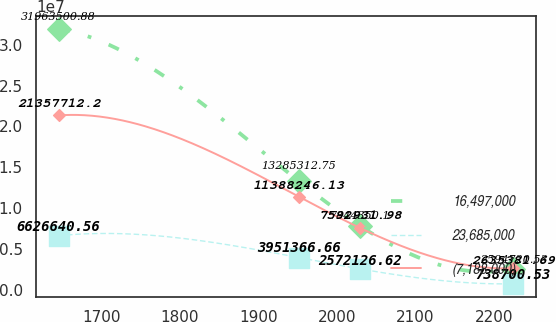Convert chart to OTSL. <chart><loc_0><loc_0><loc_500><loc_500><line_chart><ecel><fcel>16,497,000<fcel>23,685,000<fcel>(7,188,000)<nl><fcel>1645.74<fcel>3.19635e+07<fcel>6.62664e+06<fcel>2.13577e+07<nl><fcel>1952.09<fcel>1.32853e+07<fcel>3.95137e+06<fcel>1.13882e+07<nl><fcel>2029.46<fcel>7.84435e+06<fcel>2.57213e+06<fcel>7.59293e+06<nl><fcel>2225.13<fcel>2.59472e+06<fcel>738701<fcel>2.63538e+06<nl></chart> 